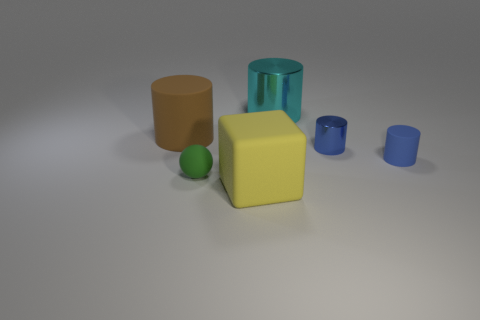There is a brown matte cylinder; is it the same size as the matte cylinder right of the green thing?
Provide a short and direct response. No. What color is the matte cylinder to the left of the big matte thing right of the tiny matte thing on the left side of the large matte block?
Provide a short and direct response. Brown. Are the object that is in front of the green object and the big cyan cylinder made of the same material?
Provide a short and direct response. No. How many other things are there of the same material as the small green ball?
Your answer should be compact. 3. What is the material of the brown thing that is the same size as the yellow matte cube?
Your answer should be compact. Rubber. Does the large object behind the big brown thing have the same shape as the rubber object that is left of the rubber ball?
Provide a short and direct response. Yes. What shape is the brown matte thing that is the same size as the block?
Offer a very short reply. Cylinder. Are the thing in front of the ball and the big cylinder that is on the left side of the block made of the same material?
Offer a very short reply. Yes. Are there any tiny blue shiny cylinders in front of the large matte thing that is behind the tiny metallic cylinder?
Offer a terse response. Yes. The big cylinder that is made of the same material as the small green ball is what color?
Your answer should be compact. Brown. 